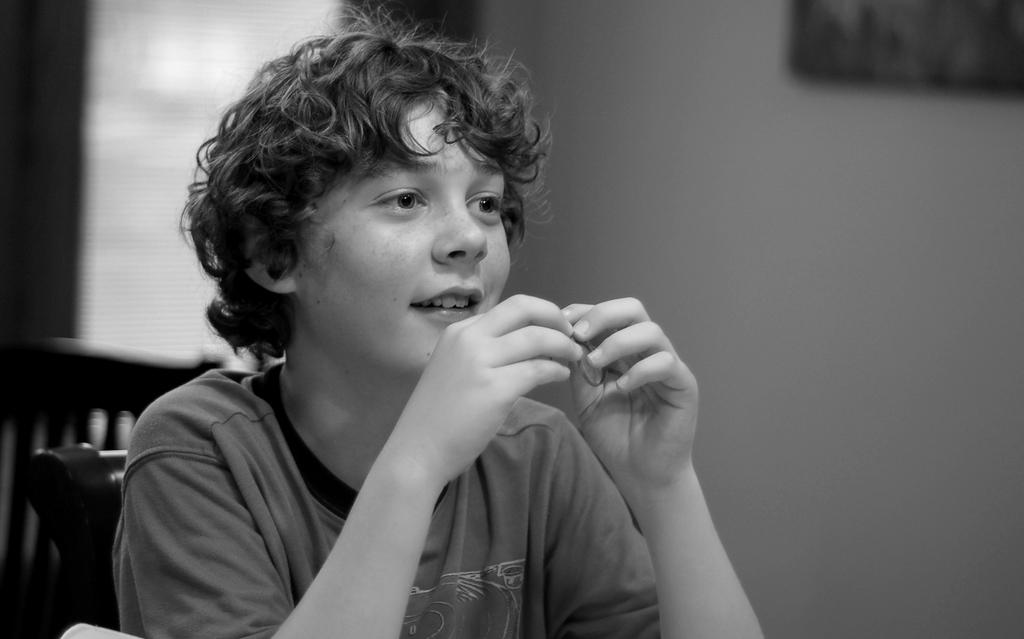What is the color scheme of the image? The image is black and white. What is the person in the image doing? The person is sitting on a chair in the image. What can be seen in the background of the image? There is a wall and at least one chair in the background of the image. Are there any other objects visible in the background? Yes, there are other objects visible in the background of the image. Can you see a boat sailing in the ocean in the image? There is no boat or ocean present in the image; it is a black and white image featuring a person sitting on a chair with a background containing a wall and other objects. 